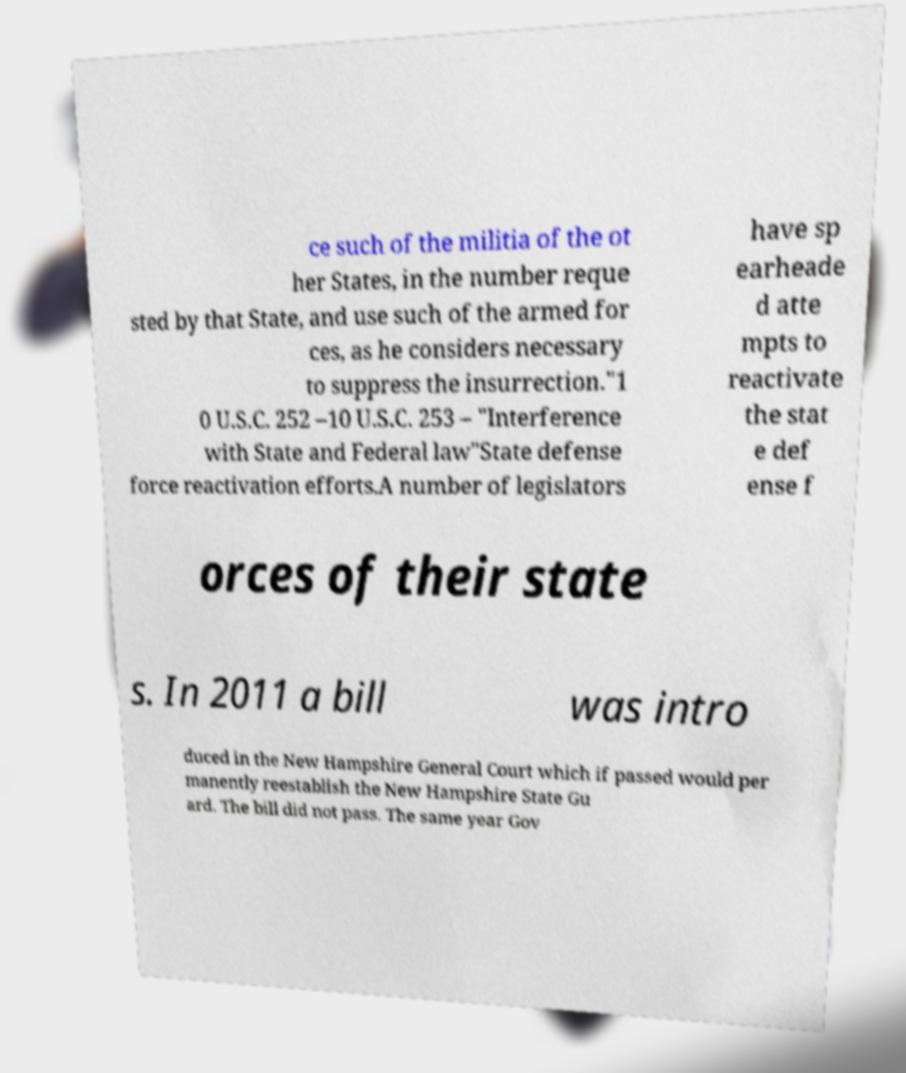What messages or text are displayed in this image? I need them in a readable, typed format. ce such of the militia of the ot her States, in the number reque sted by that State, and use such of the armed for ces, as he considers necessary to suppress the insurrection."1 0 U.S.C. 252 –10 U.S.C. 253 – "Interference with State and Federal law"State defense force reactivation efforts.A number of legislators have sp earheade d atte mpts to reactivate the stat e def ense f orces of their state s. In 2011 a bill was intro duced in the New Hampshire General Court which if passed would per manently reestablish the New Hampshire State Gu ard. The bill did not pass. The same year Gov 